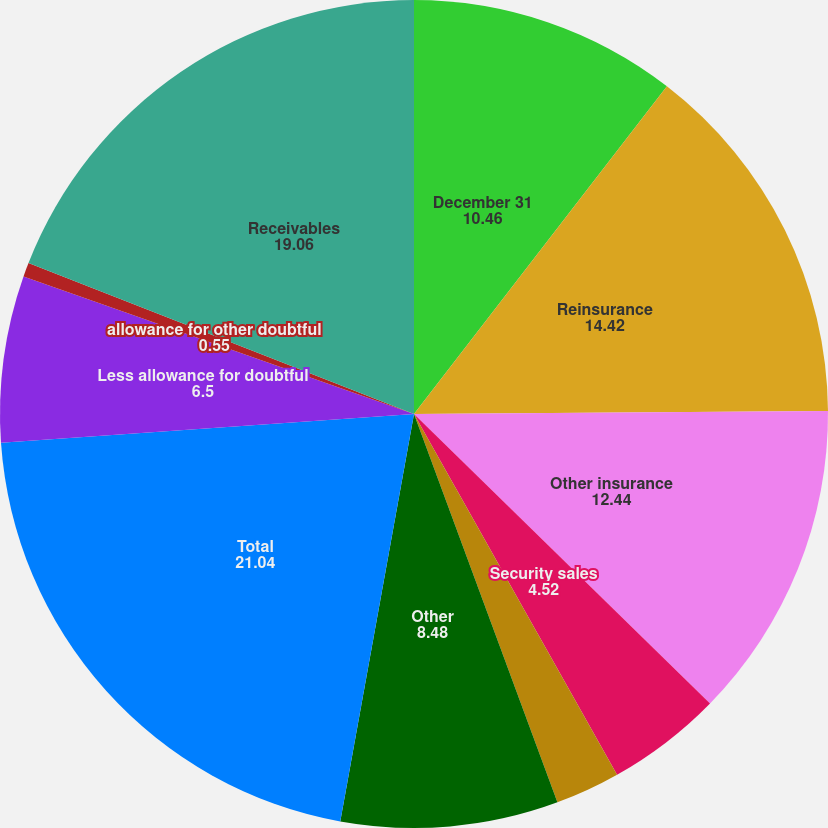Convert chart to OTSL. <chart><loc_0><loc_0><loc_500><loc_500><pie_chart><fcel>December 31<fcel>Reinsurance<fcel>Other insurance<fcel>Security sales<fcel>Accrued investment income<fcel>Other<fcel>Total<fcel>Less allowance for doubtful<fcel>allowance for other doubtful<fcel>Receivables<nl><fcel>10.46%<fcel>14.42%<fcel>12.44%<fcel>4.52%<fcel>2.53%<fcel>8.48%<fcel>21.04%<fcel>6.5%<fcel>0.55%<fcel>19.06%<nl></chart> 